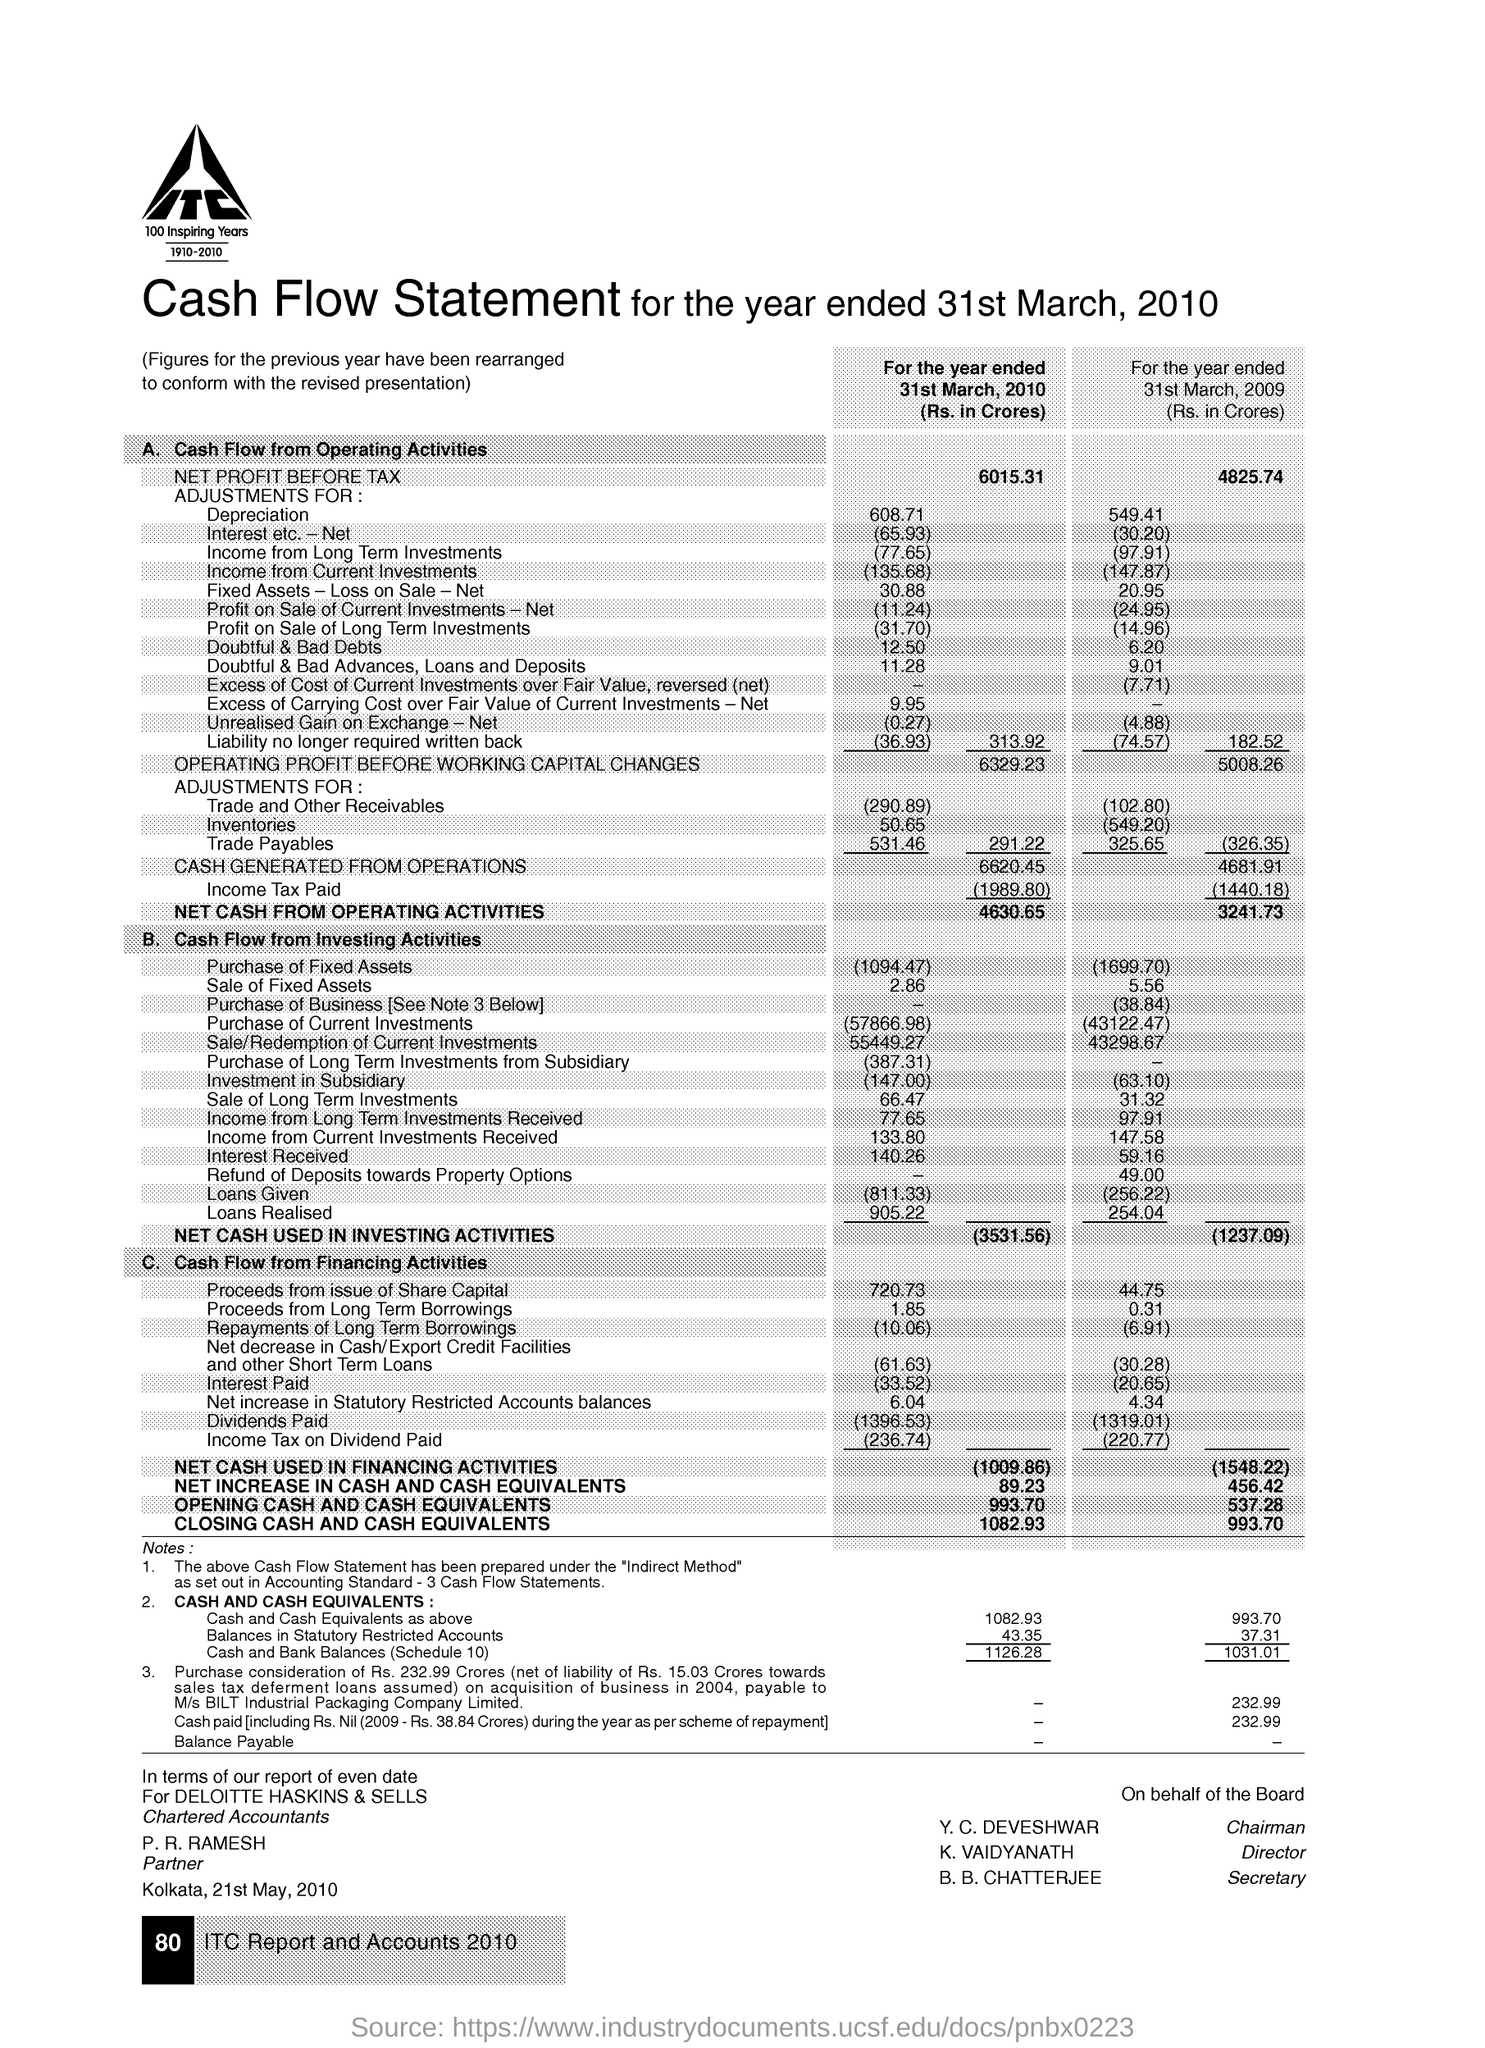Who is the chairman mentioned in the given statement ?
Your response must be concise. Y.C.Deveshwar. 